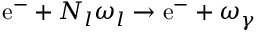<formula> <loc_0><loc_0><loc_500><loc_500>e ^ { - } + N _ { l } \omega _ { l } \rightarrow e ^ { - } + \omega _ { \gamma }</formula> 